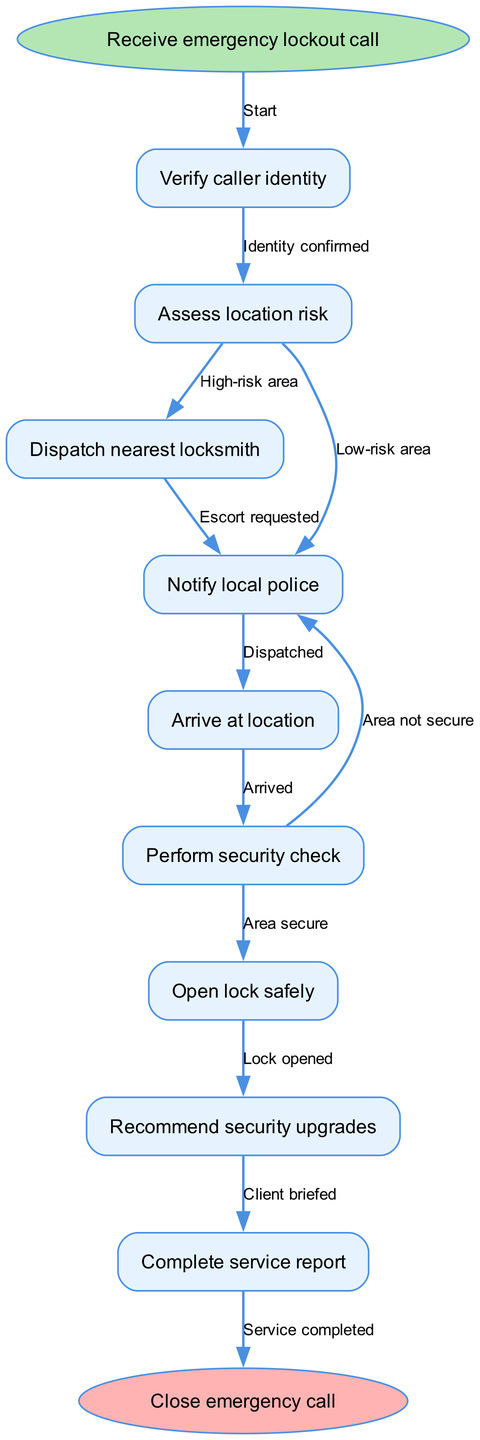What is the starting point of the workflow? The diagram begins with the "Receive emergency lockout call" node, indicating the initial step in the process.
Answer: Receive emergency lockout call How many nodes are present in the diagram? The diagram contains 9 nodes: 1 start node, 7 process nodes, and 1 end node, totaling 9 nodes.
Answer: 9 Which node follows "Verify caller identity"? After verifying the caller's identity, the next node is "Assess location risk," which represents the assessment stage of the workflow.
Answer: Assess location risk What happens after arriving at the location? Upon arrival, the next step involves "Perform security check," focusing on ensuring the area is secure before proceeding.
Answer: Perform security check What is the second edge leading from "Assess location risk"? The second edge represents the transition to notifying the local police, indicating an action taken when the area is assessed as high risk.
Answer: Notify local police Which node leads to the completion of the emergency call? The workflow progresses to "Close emergency call" from "Complete service report," signifying the end of the process after the service is documented.
Answer: Complete service report What edge indicates a secure area? The edge labeled "Area secure" connects the "Perform security check" node to the "Open lock safely" node, confirming readiness to proceed in a secure environment.
Answer: Area secure How many edges are noted in the diagram? There are 9 edges in total, representing the various transitions and actions taken between the nodes throughout the workflow.
Answer: 9 What is the last action taken before closing the emergency call? The last action taken is "Complete service report," where all details of the service provided are finalized before the call is closed.
Answer: Complete service report 